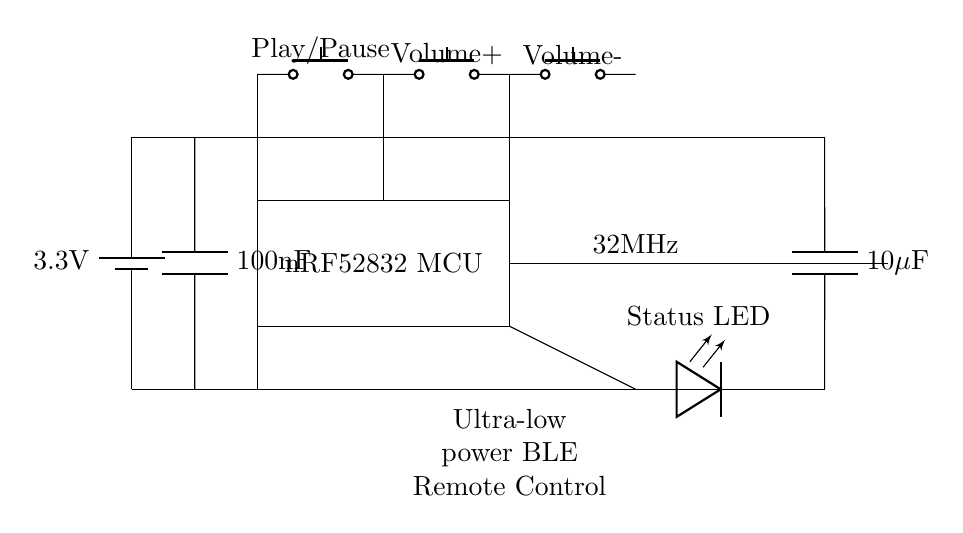What is the main power supply voltage? The main power supply voltage is 3.3 volts, indicated by the battery symbol at the top of the circuit diagram.
Answer: 3.3 volts What type of microcontroller is used? The microcontroller used in this circuit is the nRF52832, which is specified within the rectangular box in the diagram.
Answer: nRF52832 How many buttons are shown in the circuit? There are four buttons in the circuit, identified by the push button symbols connected at the top part of the circuit diagram.
Answer: Four What is the purpose of the decoupling capacitors? The decoupling capacitors are used to stabilize the power supply by filtering out noise, which is evident from their placement parallel to the power lines near the microcontroller.
Answer: Stabilizing power supply What type of connection is shown between the microcontroller and the oscillator? The connection between the microcontroller and the oscillator is a direct line, indicating a typical signal connection for clock distribution or frequency reference, which helps the microcontroller operate at a specific frequency.
Answer: Direct connection What is the function of the antenna in this circuit? The antenna is used for wireless communication, allowing the remote control to send signals to the streaming device, which is highlighted by its location at the end of the circuit diagram following the oscillator.
Answer: Wireless communication What is indicated by the Status LED in the circuit? The Status LED provides feedback on the operational state of the remote control, turning on or off to indicate whether the device is active or not, positioned towards the bottom.
Answer: Device status indication 